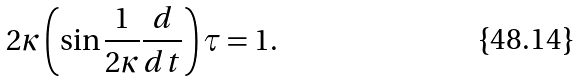Convert formula to latex. <formula><loc_0><loc_0><loc_500><loc_500>2 \kappa \left ( \sin \frac { 1 } { 2 \kappa } \frac { d } { d t } \right ) \tau = 1 .</formula> 